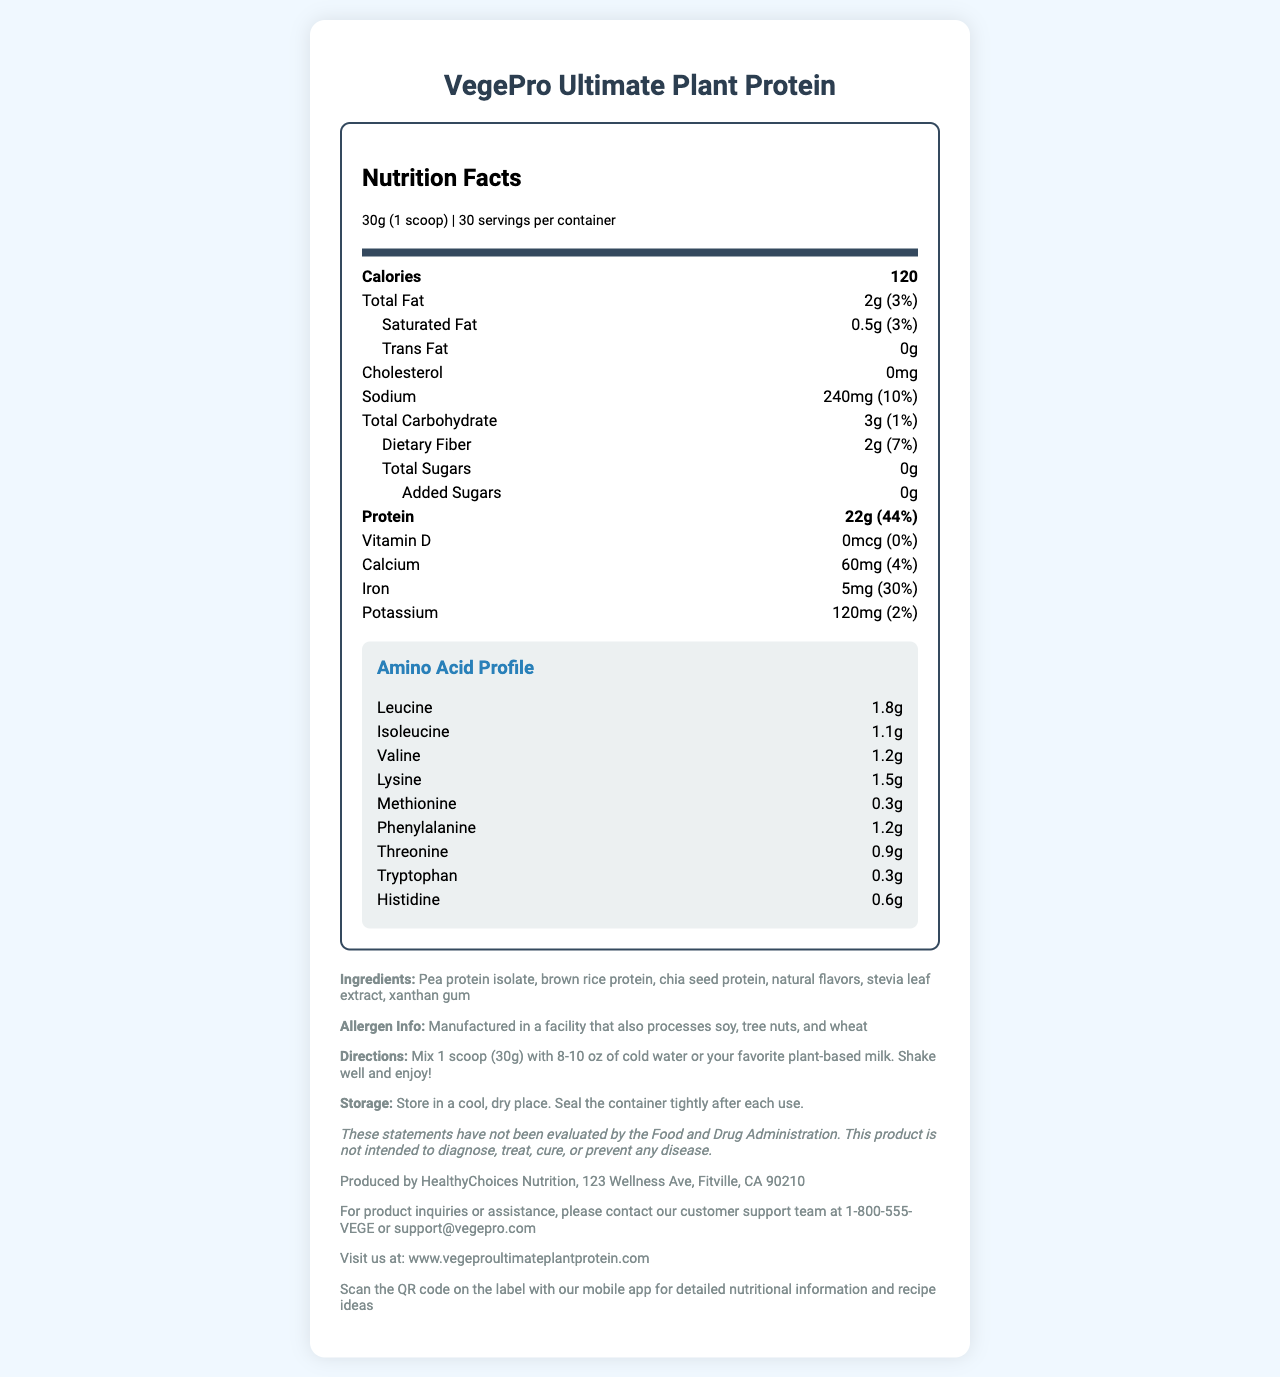what is the serving size of VegePro Ultimate Plant Protein? The serving size is explicitly stated as "30g (1 scoop)" in the document.
Answer: 30g (1 scoop) how many servings are there per container? The document states that there are 30 servings per container.
Answer: 30 what is the total fat content per serving? The total fat content per serving is listed as "2g".
Answer: 2g what is the amount of protein per serving? The document specifies that there are 22g of protein per serving.
Answer: 22g how much sodium is in each serving? The sodium content per serving is provided as "240mg".
Answer: 240mg what is the percentage of daily value for dietary fiber? The percentage of daily value for dietary fiber is listed as "7%".
Answer: 7% does VegePro Ultimate Plant Protein contain any added sugars? The document shows that the amount of added sugars is "0g".
Answer: No what are the primary ingredients in VegePro Ultimate Plant Protein? The primary ingredients are listed in the ingredients section.
Answer: Pea protein isolate, brown rice protein, chia seed protein, natural flavors, stevia leaf extract, xanthan gum what is the recommended mixing instruction for VegePro Ultimate Plant Protein? The directions state to mix 1 scoop with 8-10 oz of liquid, shake well, and enjoy.
Answer: Mix 1 scoop (30g) with 8-10 oz of cold water or your favorite plant-based milk. Shake well and enjoy! what is the manufacturer information for VegePro Ultimate Plant Protein? The manufacturer information is provided in the additional info section.
Answer: Produced by HealthyChoices Nutrition, 123 Wellness Ave, Fitville, CA 90210 which amino acid has the highest content in VegePro Ultimate Plant Protein? (A. Methionine B. Leucine C. Histidine) Leucine has the highest content with 1.8g, compared to methionine (0.3g) and histidine (0.6g).
Answer: B. Leucine what is the cholesterol content per serving? (A. 0mg B. 5mg C. 10mg) The cholesterol content per serving is specified as "0mg".
Answer: A. 0mg is VegePro Ultimate Plant Protein suitable for those avoiding trans fats? The trans fat content per serving is "0g".
Answer: Yes how should one store VegePro Ultimate Plant Protein? The storage instructions advise storing in a cool, dry place and sealing the container tightly after use.
Answer: Store in a cool, dry place. Seal the container tightly after each use. summarize the key details of the VegePro Ultimate Plant Protein nutrition facts label. The summary captures the essential nutritional information, ingredients, storage instructions, and other details from the document.
Answer: The VegePro Ultimate Plant Protein nutrition facts label provides details on serving size (30g), number of servings per container (30), and nutrition information such as 120 calories per serving, 2g total fat (3% daily value), 22g protein (44% daily value), sodium content (240mg, 10% daily value), and a detailed amino acid profile. It also lists the ingredients, allergen info, mixing instructions, storage recommendations, manufacturer information, and customer support contact. how does one get more detailed nutritional information or recipe ideas for VegePro Ultimate Plant Protein? The document suggests scanning the QR code on the label with the mobile app for detailed nutritional information and recipe ideas.
Answer: Scan the QR code on the label with our mobile app what is the vitamin D content per serving? The vitamin D content per serving is listed as "0mcg".
Answer: 0mcg what is the percentage of daily value for iron per serving? The document specifies that the percentage of daily value for iron per serving is 30%.
Answer: 30% does the document provide information on the protein source of VegePro Ultimate Plant Protein? The ingredients section lists pea protein isolate, brown rice protein, chia seed protein as the sources of protein.
Answer: Yes what are the contact details for customer support? The customer support contact details are provided in the additional info section.
Answer: 1-800-555-VEGE or support@vegepro.com what is the exact amino acid content of lysine in VegePro Ultimate Plant Protein? The document specifies that the lysine content is 1.5g.
Answer: 1.5g is the product suitable for someone with a nut allergy? The document states that it is manufactured in a facility that also processes tree nuts, but it does not provide a conclusive answer for someone with a nut allergy.
Answer: Cannot be determined 